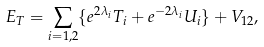<formula> <loc_0><loc_0><loc_500><loc_500>E _ { T } = \sum _ { i = 1 , 2 } \{ e ^ { 2 \lambda _ { i } } T _ { i } + e ^ { - 2 \lambda _ { i } } U _ { i } \} + V _ { 1 2 } ,</formula> 